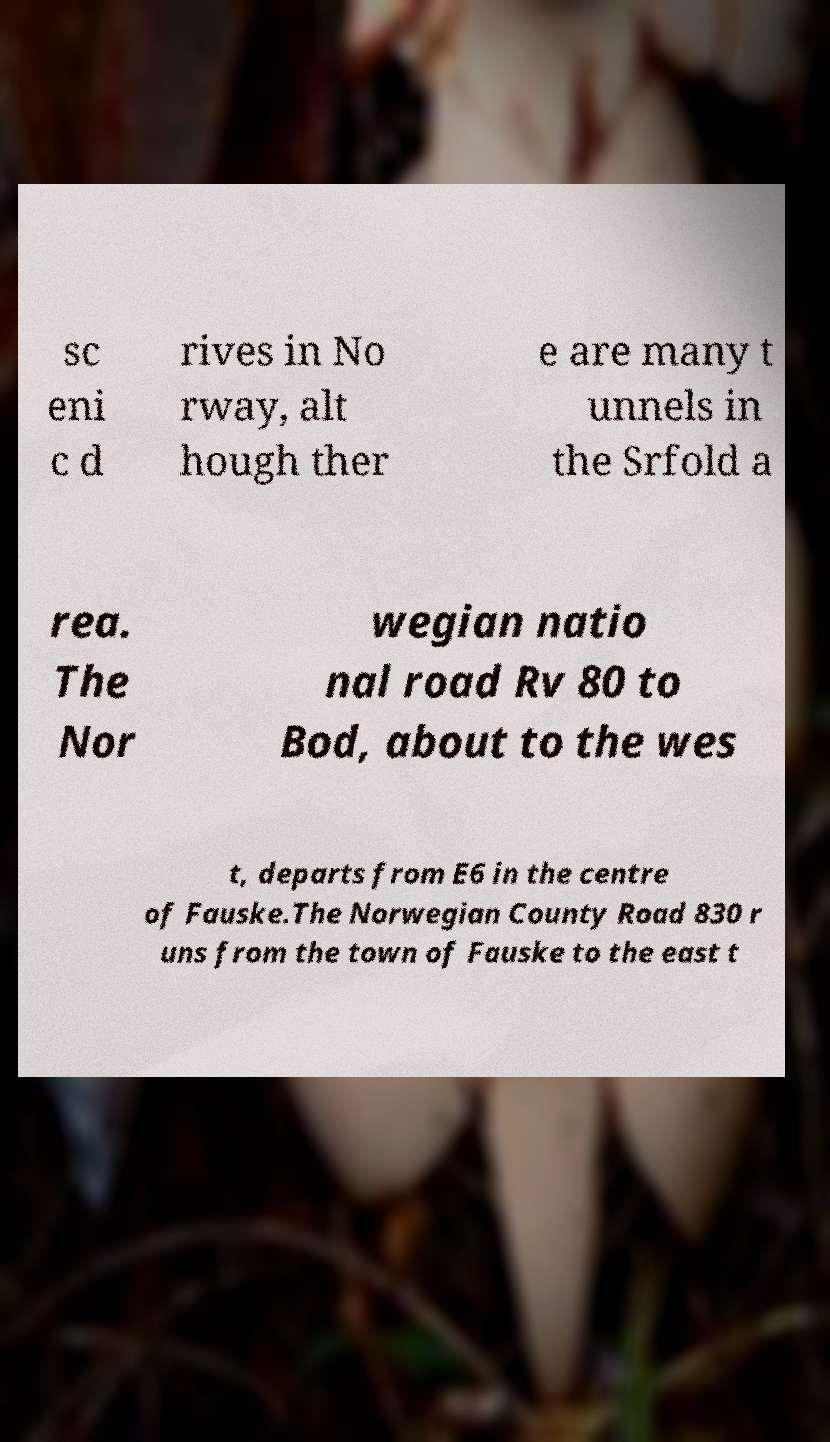Could you assist in decoding the text presented in this image and type it out clearly? sc eni c d rives in No rway, alt hough ther e are many t unnels in the Srfold a rea. The Nor wegian natio nal road Rv 80 to Bod, about to the wes t, departs from E6 in the centre of Fauske.The Norwegian County Road 830 r uns from the town of Fauske to the east t 